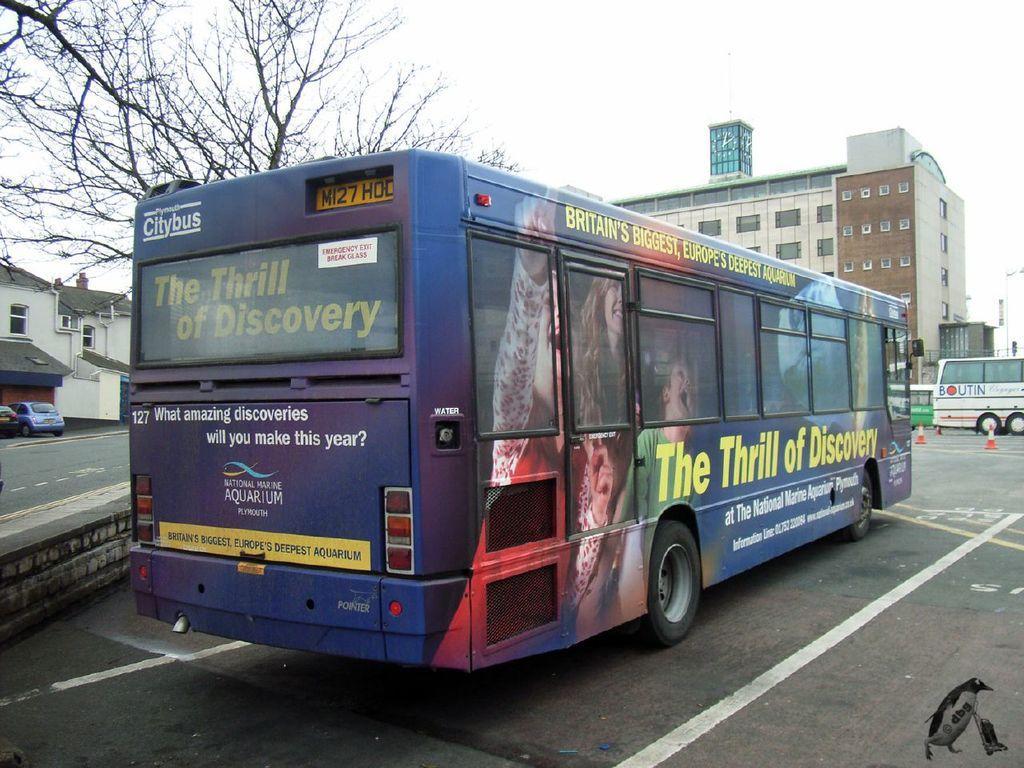Can you describe this image briefly? This bus is in blue color and there is some advertisement on this bus. It has number plate and wheels. In-front of this bus there is a building, which is in cream and brown color. In this building there is a window. The vehicles are travelling on a road. The road is in ash color. This is a house with a window, with a ash roof top. The walls in white color. In-front of this house 2 vehicles are in parking. Beside this bus there is bare tree. Sky is in white color. 